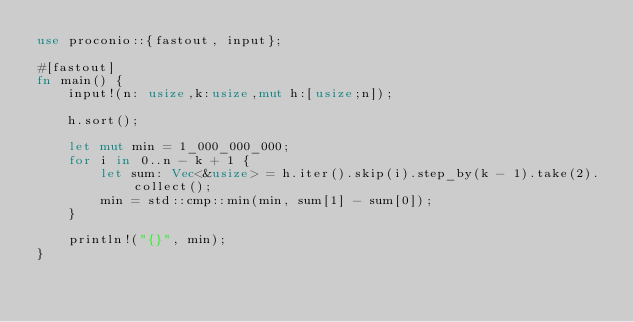<code> <loc_0><loc_0><loc_500><loc_500><_Rust_>use proconio::{fastout, input};

#[fastout]
fn main() {
    input!(n: usize,k:usize,mut h:[usize;n]);

    h.sort();

    let mut min = 1_000_000_000;
    for i in 0..n - k + 1 {
        let sum: Vec<&usize> = h.iter().skip(i).step_by(k - 1).take(2).collect();
        min = std::cmp::min(min, sum[1] - sum[0]);
    }

    println!("{}", min);
}
</code> 